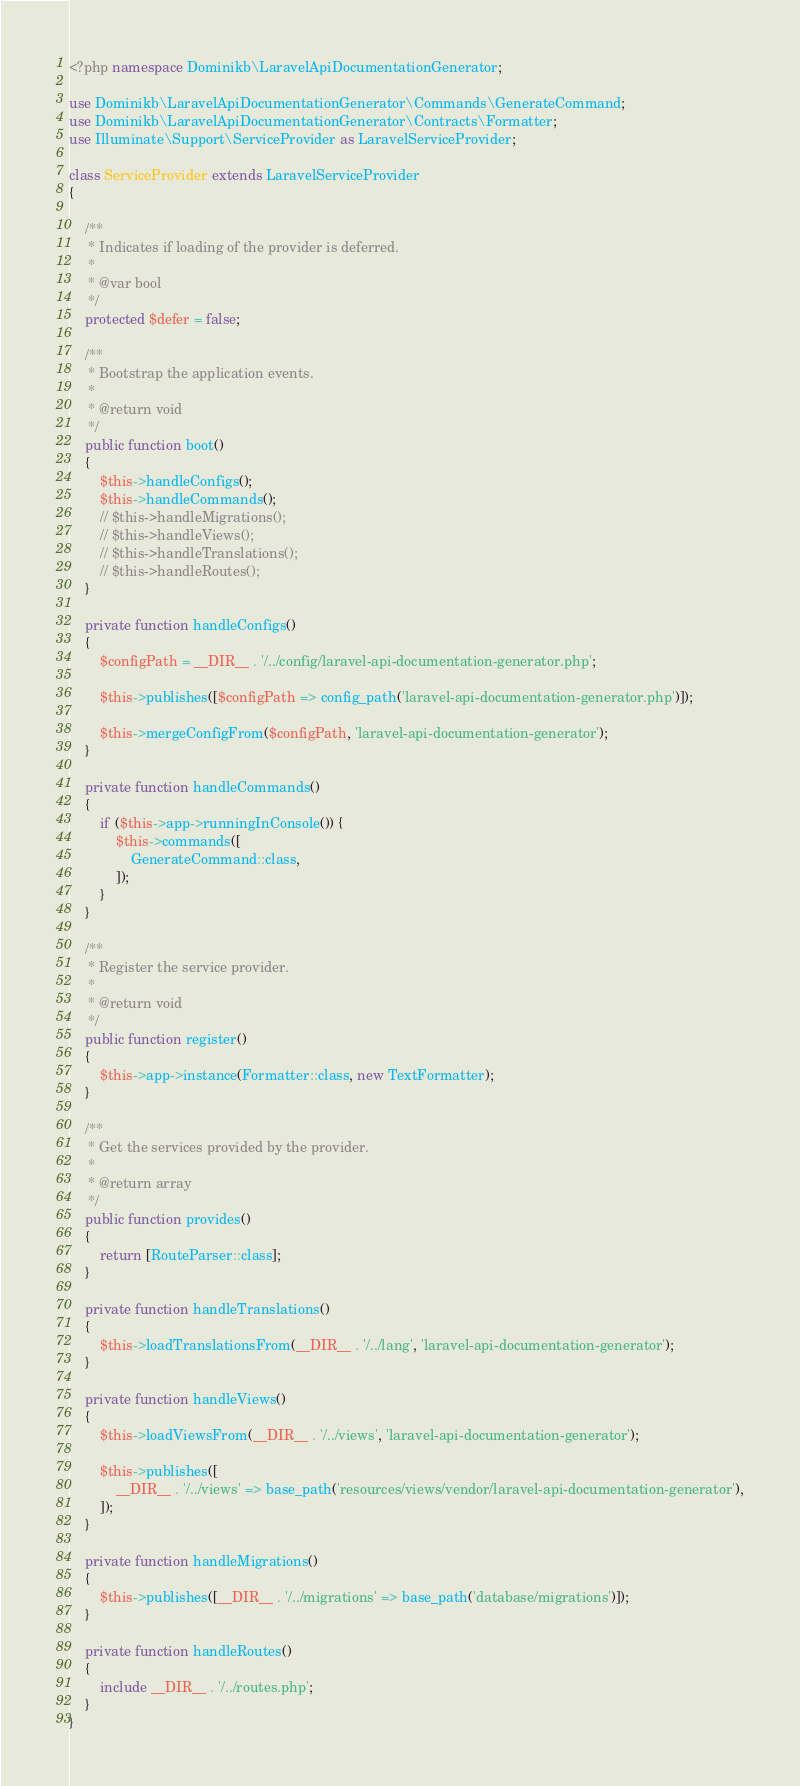Convert code to text. <code><loc_0><loc_0><loc_500><loc_500><_PHP_><?php namespace Dominikb\LaravelApiDocumentationGenerator;

use Dominikb\LaravelApiDocumentationGenerator\Commands\GenerateCommand;
use Dominikb\LaravelApiDocumentationGenerator\Contracts\Formatter;
use Illuminate\Support\ServiceProvider as LaravelServiceProvider;

class ServiceProvider extends LaravelServiceProvider
{

    /**
     * Indicates if loading of the provider is deferred.
     *
     * @var bool
     */
    protected $defer = false;

    /**
     * Bootstrap the application events.
     *
     * @return void
     */
    public function boot()
    {
        $this->handleConfigs();
        $this->handleCommands();
        // $this->handleMigrations();
        // $this->handleViews();
        // $this->handleTranslations();
        // $this->handleRoutes();
    }

    private function handleConfigs()
    {
        $configPath = __DIR__ . '/../config/laravel-api-documentation-generator.php';

        $this->publishes([$configPath => config_path('laravel-api-documentation-generator.php')]);

        $this->mergeConfigFrom($configPath, 'laravel-api-documentation-generator');
    }

    private function handleCommands()
    {
        if ($this->app->runningInConsole()) {
            $this->commands([
                GenerateCommand::class,
            ]);
        }
    }

    /**
     * Register the service provider.
     *
     * @return void
     */
    public function register()
    {
        $this->app->instance(Formatter::class, new TextFormatter);
    }

    /**
     * Get the services provided by the provider.
     *
     * @return array
     */
    public function provides()
    {
        return [RouteParser::class];
    }

    private function handleTranslations()
    {
        $this->loadTranslationsFrom(__DIR__ . '/../lang', 'laravel-api-documentation-generator');
    }

    private function handleViews()
    {
        $this->loadViewsFrom(__DIR__ . '/../views', 'laravel-api-documentation-generator');

        $this->publishes([
            __DIR__ . '/../views' => base_path('resources/views/vendor/laravel-api-documentation-generator'),
        ]);
    }

    private function handleMigrations()
    {
        $this->publishes([__DIR__ . '/../migrations' => base_path('database/migrations')]);
    }

    private function handleRoutes()
    {
        include __DIR__ . '/../routes.php';
    }
}
</code> 